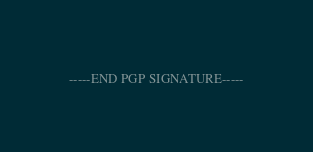<code> <loc_0><loc_0><loc_500><loc_500><_SML_>-----END PGP SIGNATURE-----
</code> 